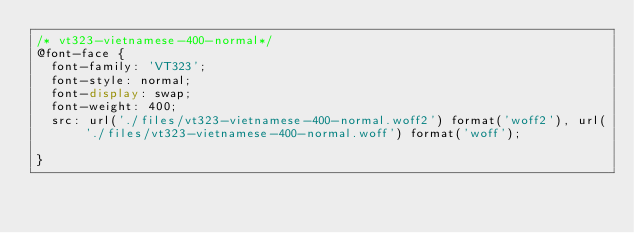Convert code to text. <code><loc_0><loc_0><loc_500><loc_500><_CSS_>/* vt323-vietnamese-400-normal*/
@font-face {
  font-family: 'VT323';
  font-style: normal;
  font-display: swap;
  font-weight: 400;
  src: url('./files/vt323-vietnamese-400-normal.woff2') format('woff2'), url('./files/vt323-vietnamese-400-normal.woff') format('woff');
  
}
</code> 